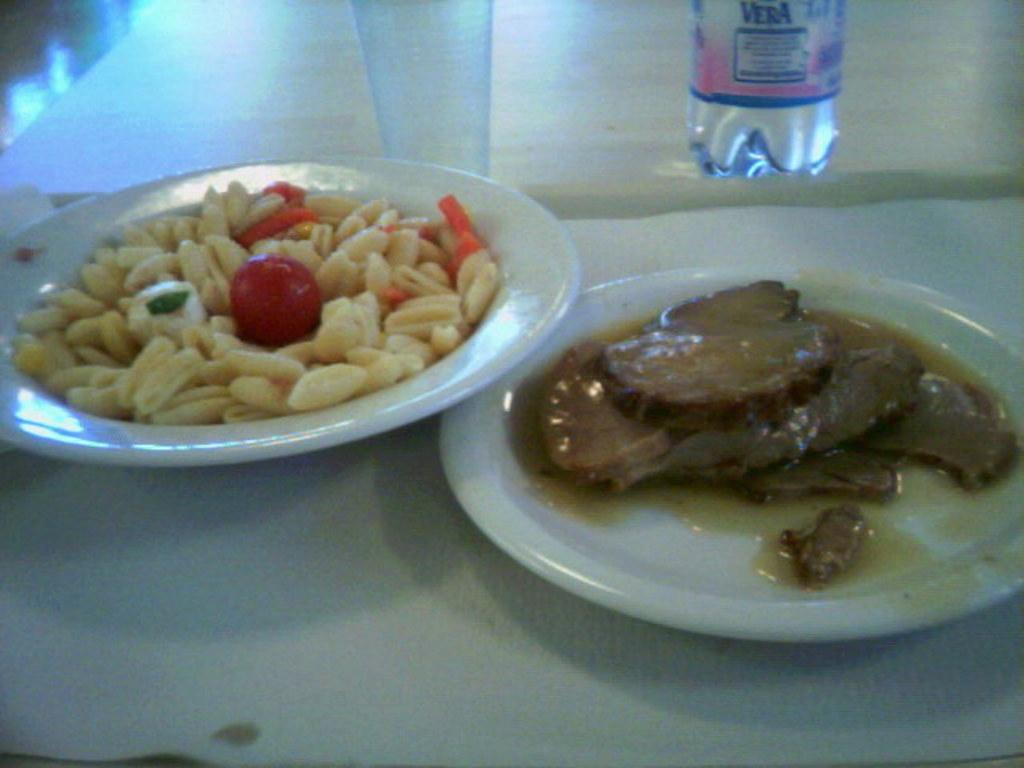What is on the plate that is visible in the image? There are food items on a plate in the image. Where is the plate located in the image? The plate is on a table in the image. What else can be seen on the table besides the plate? There is a bottle and a glass visible in the image. How many family members are present in the image? There is no indication of family members in the image; it only shows a plate with food items, a bottle, and a glass on a table. 